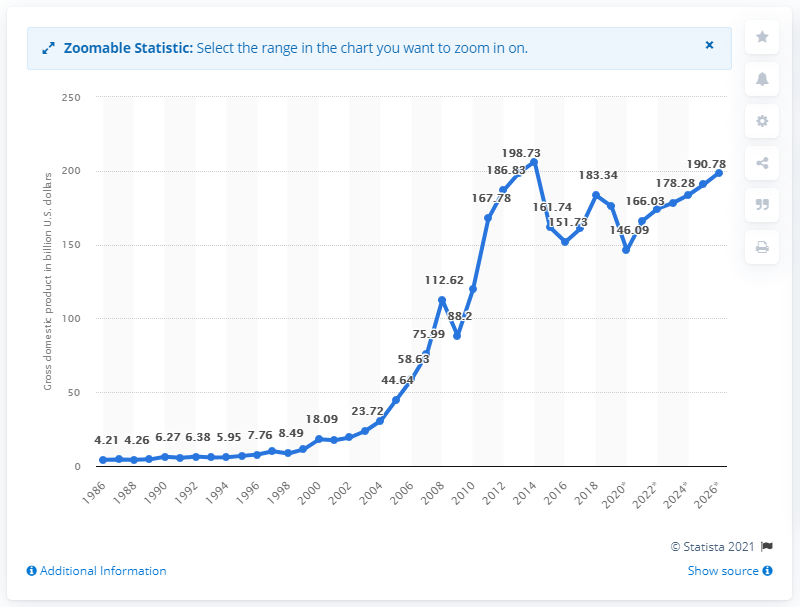Specify some key components in this picture. In 2019, Qatar's gross domestic product (GDP) was estimated to be 174.38 billion US dollars. 